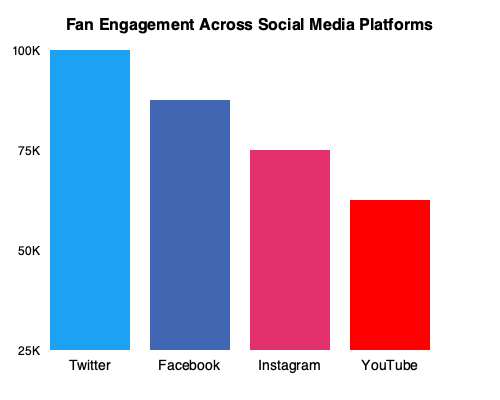Based on the bar chart showing fan engagement across different social media platforms, which platform should be prioritized for improving the team's image and reputation, and why? To answer this question, we need to analyze the data presented in the bar chart and consider its implications for the team's image and reputation. Let's break it down step-by-step:

1. Interpret the data:
   - Twitter (blue bar): Approximately 100K engagements
   - Facebook (dark blue bar): Approximately 75K engagements
   - Instagram (pink bar): Approximately 50K engagements
   - YouTube (red bar): Approximately 25K engagements

2. Identify the platform with the highest engagement:
   Twitter has the highest engagement at 100K, which indicates it has the largest audience reach and interaction.

3. Consider the implications for team image and reputation:
   - Higher engagement means more fans are actively interacting with the team's content.
   - More interactions provide greater opportunities to shape and control the team's narrative.
   - Twitter's real-time nature allows for immediate communication during games or events.

4. Evaluate the potential for improvement:
   - While Twitter already has the highest engagement, focusing on this platform can further amplify the team's message.
   - Improving content quality and frequency on Twitter can lead to even more engagement and wider reach.

5. Consider the coach's perspective:
   As a demanding coach who values the team's image and reputation, prioritizing the platform with the highest engagement aligns with the goal of maximizing positive exposure and fan interaction.

Therefore, Twitter should be prioritized for improving the team's image and reputation because it already has the highest engagement, offers real-time communication, and provides the greatest potential for amplifying the team's message to a large, active audience.
Answer: Twitter, due to highest engagement and real-time communication potential. 